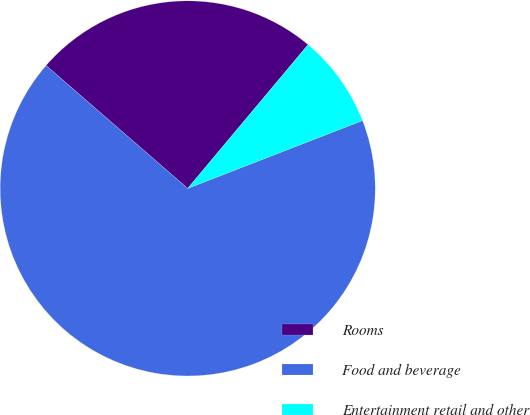Convert chart to OTSL. <chart><loc_0><loc_0><loc_500><loc_500><pie_chart><fcel>Rooms<fcel>Food and beverage<fcel>Entertainment retail and other<nl><fcel>24.72%<fcel>67.27%<fcel>8.01%<nl></chart> 